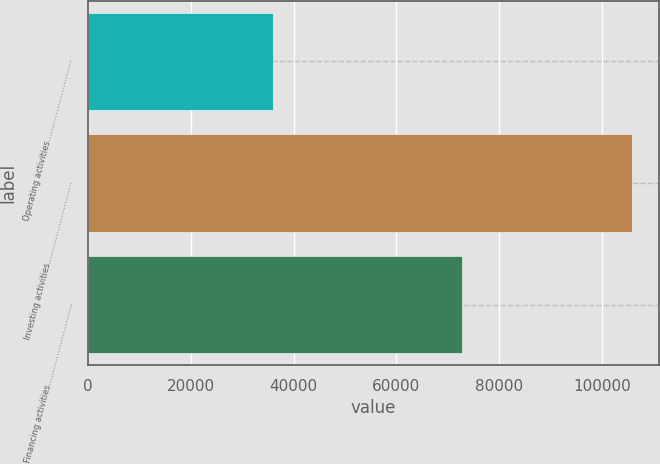Convert chart. <chart><loc_0><loc_0><loc_500><loc_500><bar_chart><fcel>Operating activities…………………………<fcel>Investing activities…………………………<fcel>Financing activities…………………………<nl><fcel>35956<fcel>105866<fcel>72851<nl></chart> 